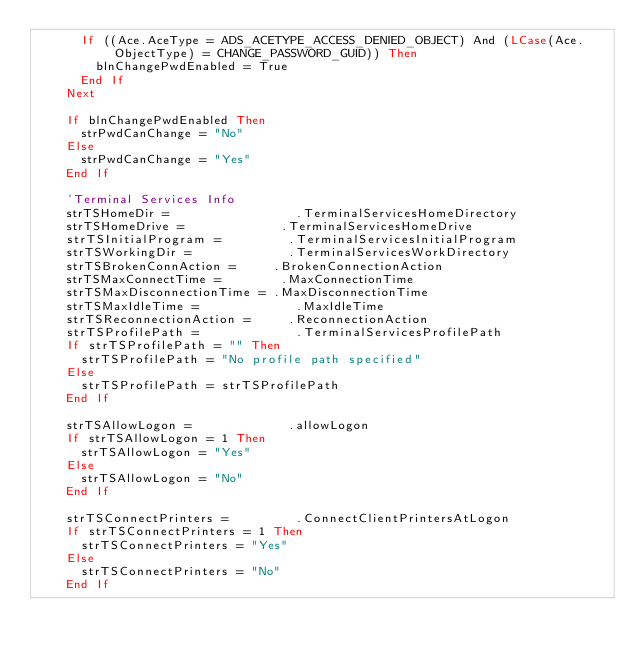Convert code to text. <code><loc_0><loc_0><loc_500><loc_500><_VisualBasic_>      If ((Ace.AceType = ADS_ACETYPE_ACCESS_DENIED_OBJECT) And (LCase(Ace.ObjectType) = CHANGE_PASSWORD_GUID)) Then
        blnChangePwdEnabled = True
      End If
    Next
    
    If blnChangePwdEnabled Then
      strPwdCanChange = "No"
    Else
      strPwdCanChange = "Yes"
    End If
    
    'Terminal Services Info
    strTSHomeDir =                 .TerminalServicesHomeDirectory
    strTSHomeDrive =             .TerminalServicesHomeDrive
    strTSInitialProgram =         .TerminalServicesInitialProgram
    strTSWorkingDir =             .TerminalServicesWorkDirectory
    strTSBrokenConnAction =     .BrokenConnectionAction
    strTSMaxConnectTime =        .MaxConnectionTime
    strTSMaxDisconnectionTime = .MaxDisconnectionTime
    strTSMaxIdleTime =             .MaxIdleTime
    strTSReconnectionAction =     .ReconnectionAction
    strTSProfilePath =             .TerminalServicesProfilePath
    If strTSProfilePath = "" Then
      strTSProfilePath = "No profile path specified"
    Else
      strTSProfilePath = strTSProfilePath
    End If
    
    strTSAllowLogon =             .allowLogon
    If strTSAllowLogon = 1 Then
      strTSAllowLogon = "Yes"
    Else
      strTSAllowLogon = "No"
    End If
    
    strTSConnectPrinters =         .ConnectClientPrintersAtLogon
    If strTSConnectPrinters = 1 Then
      strTSConnectPrinters = "Yes"
    Else
      strTSConnectPrinters = "No"
    End If
    </code> 